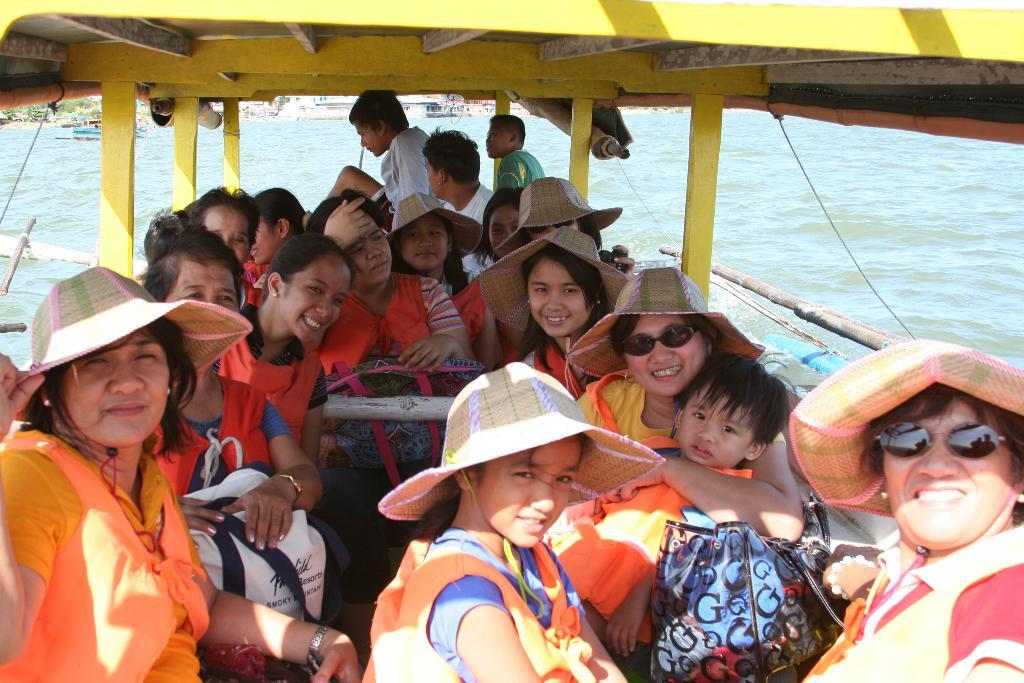What are the people in the image doing? There is a group of people in a boat in the image. Where is the boat located? The boat is in the water. What can be seen in the background of the image? There are other boats visible in the background, and water is present as well. What rhythm is the boat following in the image? The boat does not follow a rhythm in the image; it is stationary in the water. How many fingers can be seen on the people in the boat? The number of fingers on the people in the boat cannot be determined from the image. 